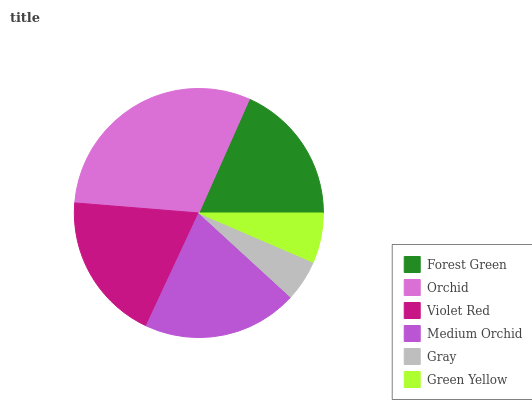Is Gray the minimum?
Answer yes or no. Yes. Is Orchid the maximum?
Answer yes or no. Yes. Is Violet Red the minimum?
Answer yes or no. No. Is Violet Red the maximum?
Answer yes or no. No. Is Orchid greater than Violet Red?
Answer yes or no. Yes. Is Violet Red less than Orchid?
Answer yes or no. Yes. Is Violet Red greater than Orchid?
Answer yes or no. No. Is Orchid less than Violet Red?
Answer yes or no. No. Is Violet Red the high median?
Answer yes or no. Yes. Is Forest Green the low median?
Answer yes or no. Yes. Is Green Yellow the high median?
Answer yes or no. No. Is Gray the low median?
Answer yes or no. No. 